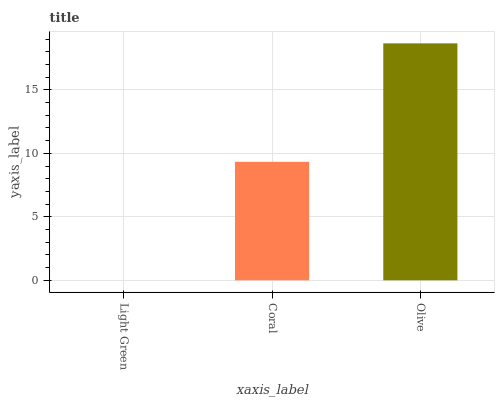Is Coral the minimum?
Answer yes or no. No. Is Coral the maximum?
Answer yes or no. No. Is Coral greater than Light Green?
Answer yes or no. Yes. Is Light Green less than Coral?
Answer yes or no. Yes. Is Light Green greater than Coral?
Answer yes or no. No. Is Coral less than Light Green?
Answer yes or no. No. Is Coral the high median?
Answer yes or no. Yes. Is Coral the low median?
Answer yes or no. Yes. Is Olive the high median?
Answer yes or no. No. Is Light Green the low median?
Answer yes or no. No. 